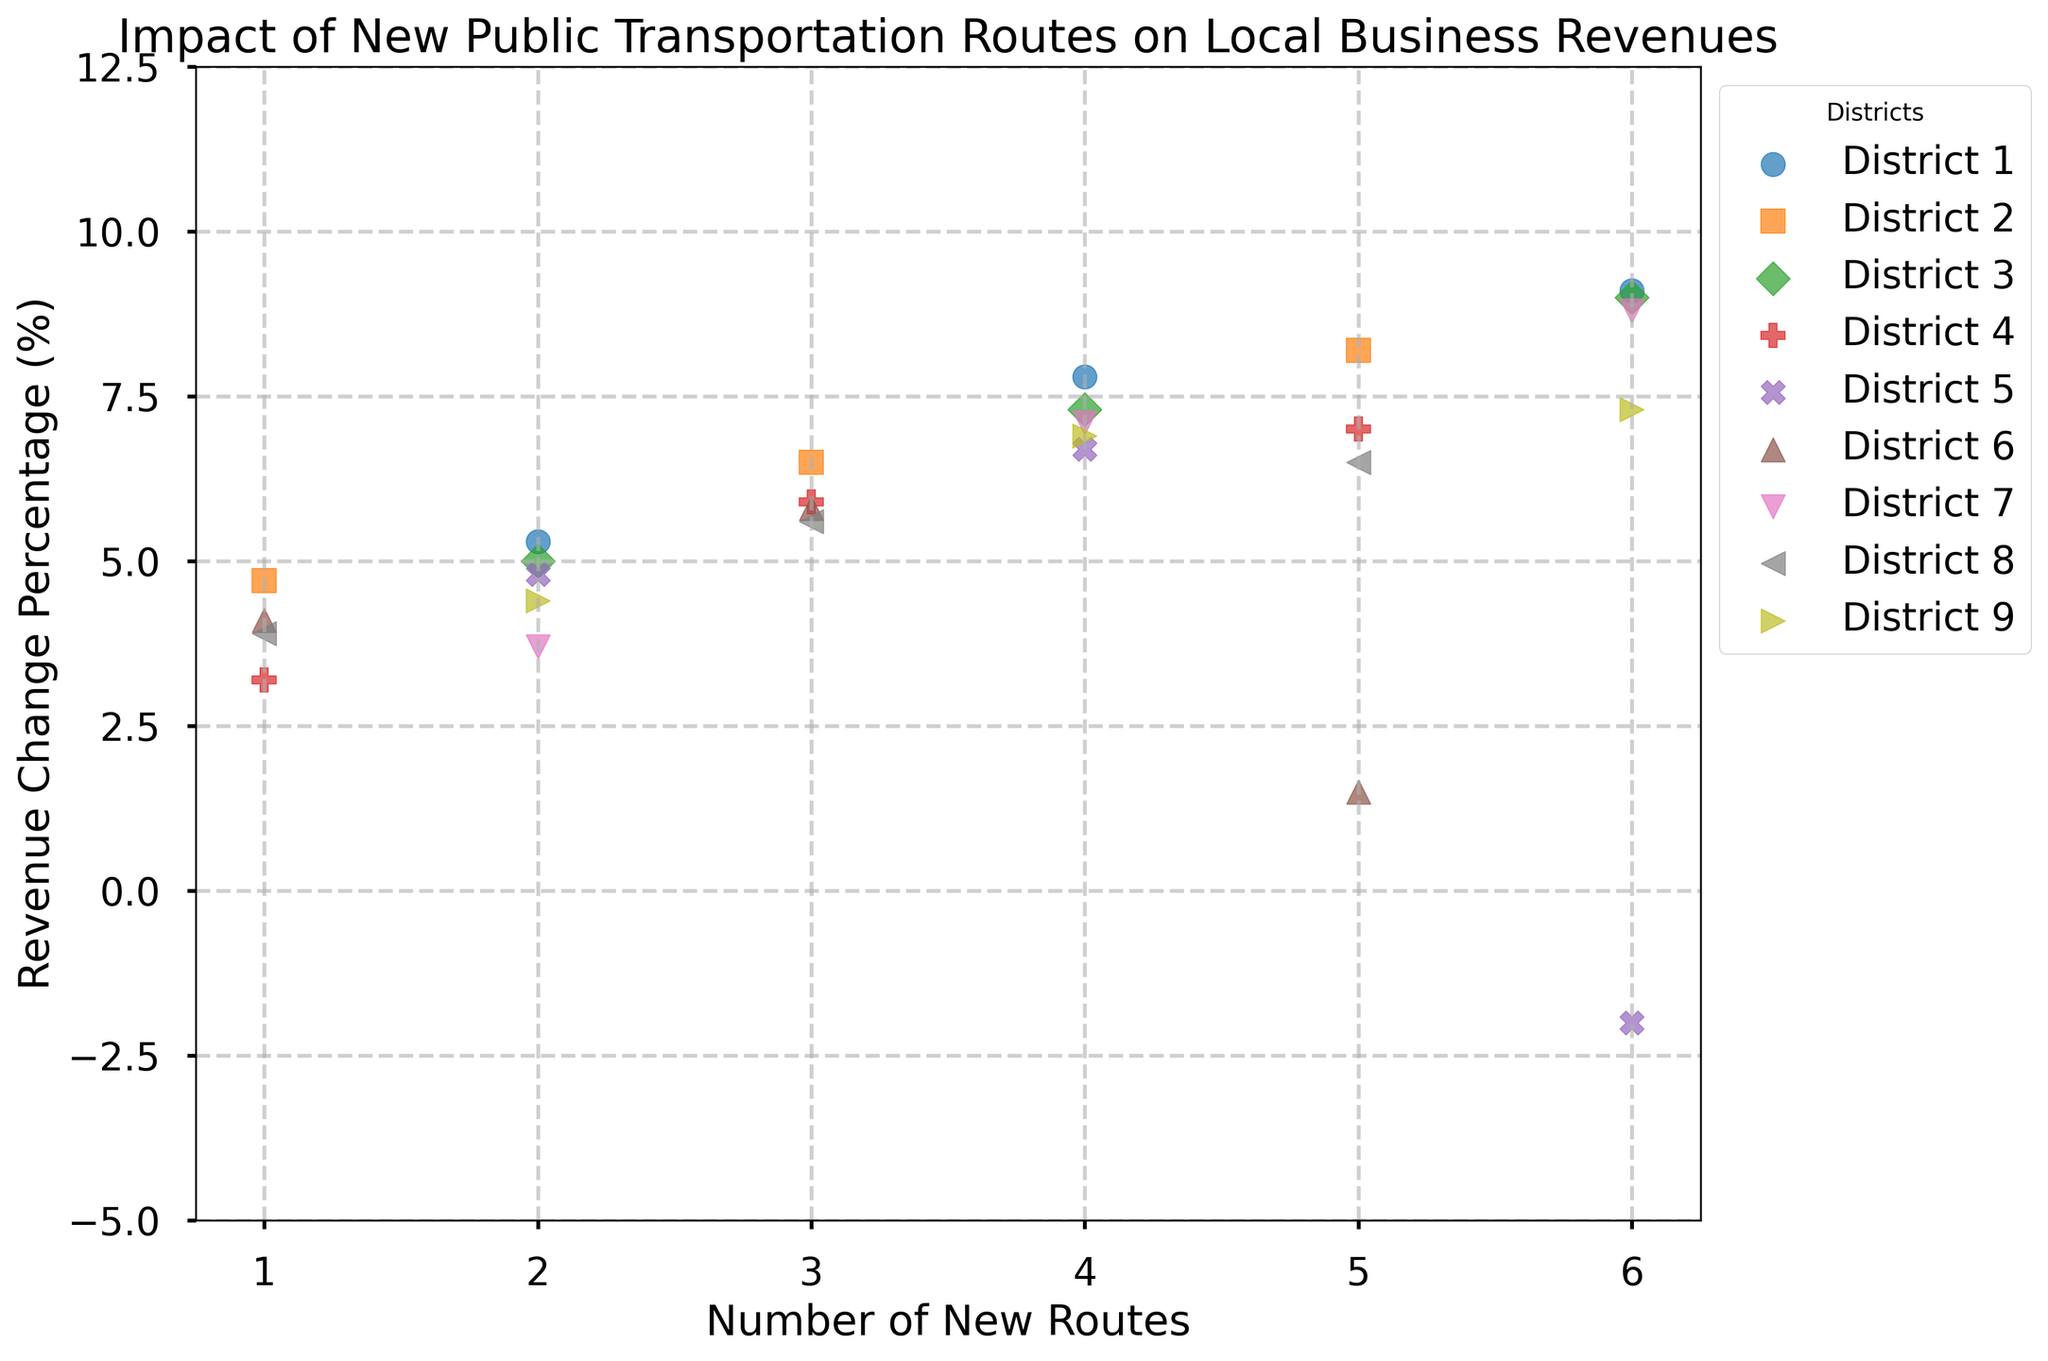What general trend do you notice between the number of new routes and the revenue change percentage? As the number of new routes increases, the revenue change percentage tends to increase as well in most districts. This suggests a positive correlation between the number of new transportation routes and business revenue.
Answer: Positive correlation Which district shows a negative revenue change percentage with a higher number of new routes? By examining the scatter plot, District 5 shows a negative revenue change percentage (-2.0%) when there are 6 new routes.
Answer: District 5 Compare the revenue change percentage between District 2 and District 8 with three new routes each. Which one has a higher value? District 2 has a revenue change percentage of 6.5%, while District 8 has a revenue change percentage of 5.6%. Therefore, District 2 has a higher value.
Answer: District 2 What is the average revenue change percentage for District 4? For District 4, the revenue change percentages are 3.2%, 5.9%, and 7.0%. The average is calculated as (3.2 + 5.9 + 7.0) / 3 = 5.37%.
Answer: 5.37% Which district shows the highest revenue change percentage overall and with how many new routes? The scatter plot indicates that District 1 has the highest revenue change percentage of 9.1%, which occurs with 6 new routes.
Answer: District 1, 6 new routes Does District 7 show a consistent increase in revenue change percentage with an increase in new routes? For District 7, the revenue change percentages are 3.7% (with 2 routes), 7.1% (with 4 routes), and 8.8% (with 6 routes). As the number of routes increases, the revenue change percentage also increases consistently.
Answer: Yes What is the difference in the revenue change percentage between the maximum and minimum values for District 6? For District 6, the revenue change percentages are 4.1%, 5.8%, and 1.5%. The maximum value is 5.8% and the minimum is 1.5%. The difference is 5.8% - 1.5% = 4.3%.
Answer: 4.3% Which districts show a revenue change percentage around 5.0% with two new routes? Districts 3 and 5 both show a revenue change percentage around 5.0% with two new routes. District 3 is exactly at 5.0%, and District 5 is at 4.8%.
Answer: Districts 3 and 5 